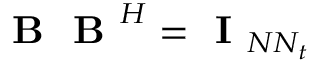<formula> <loc_0><loc_0><loc_500><loc_500>B B ^ { H } = I _ { N N _ { t } }</formula> 